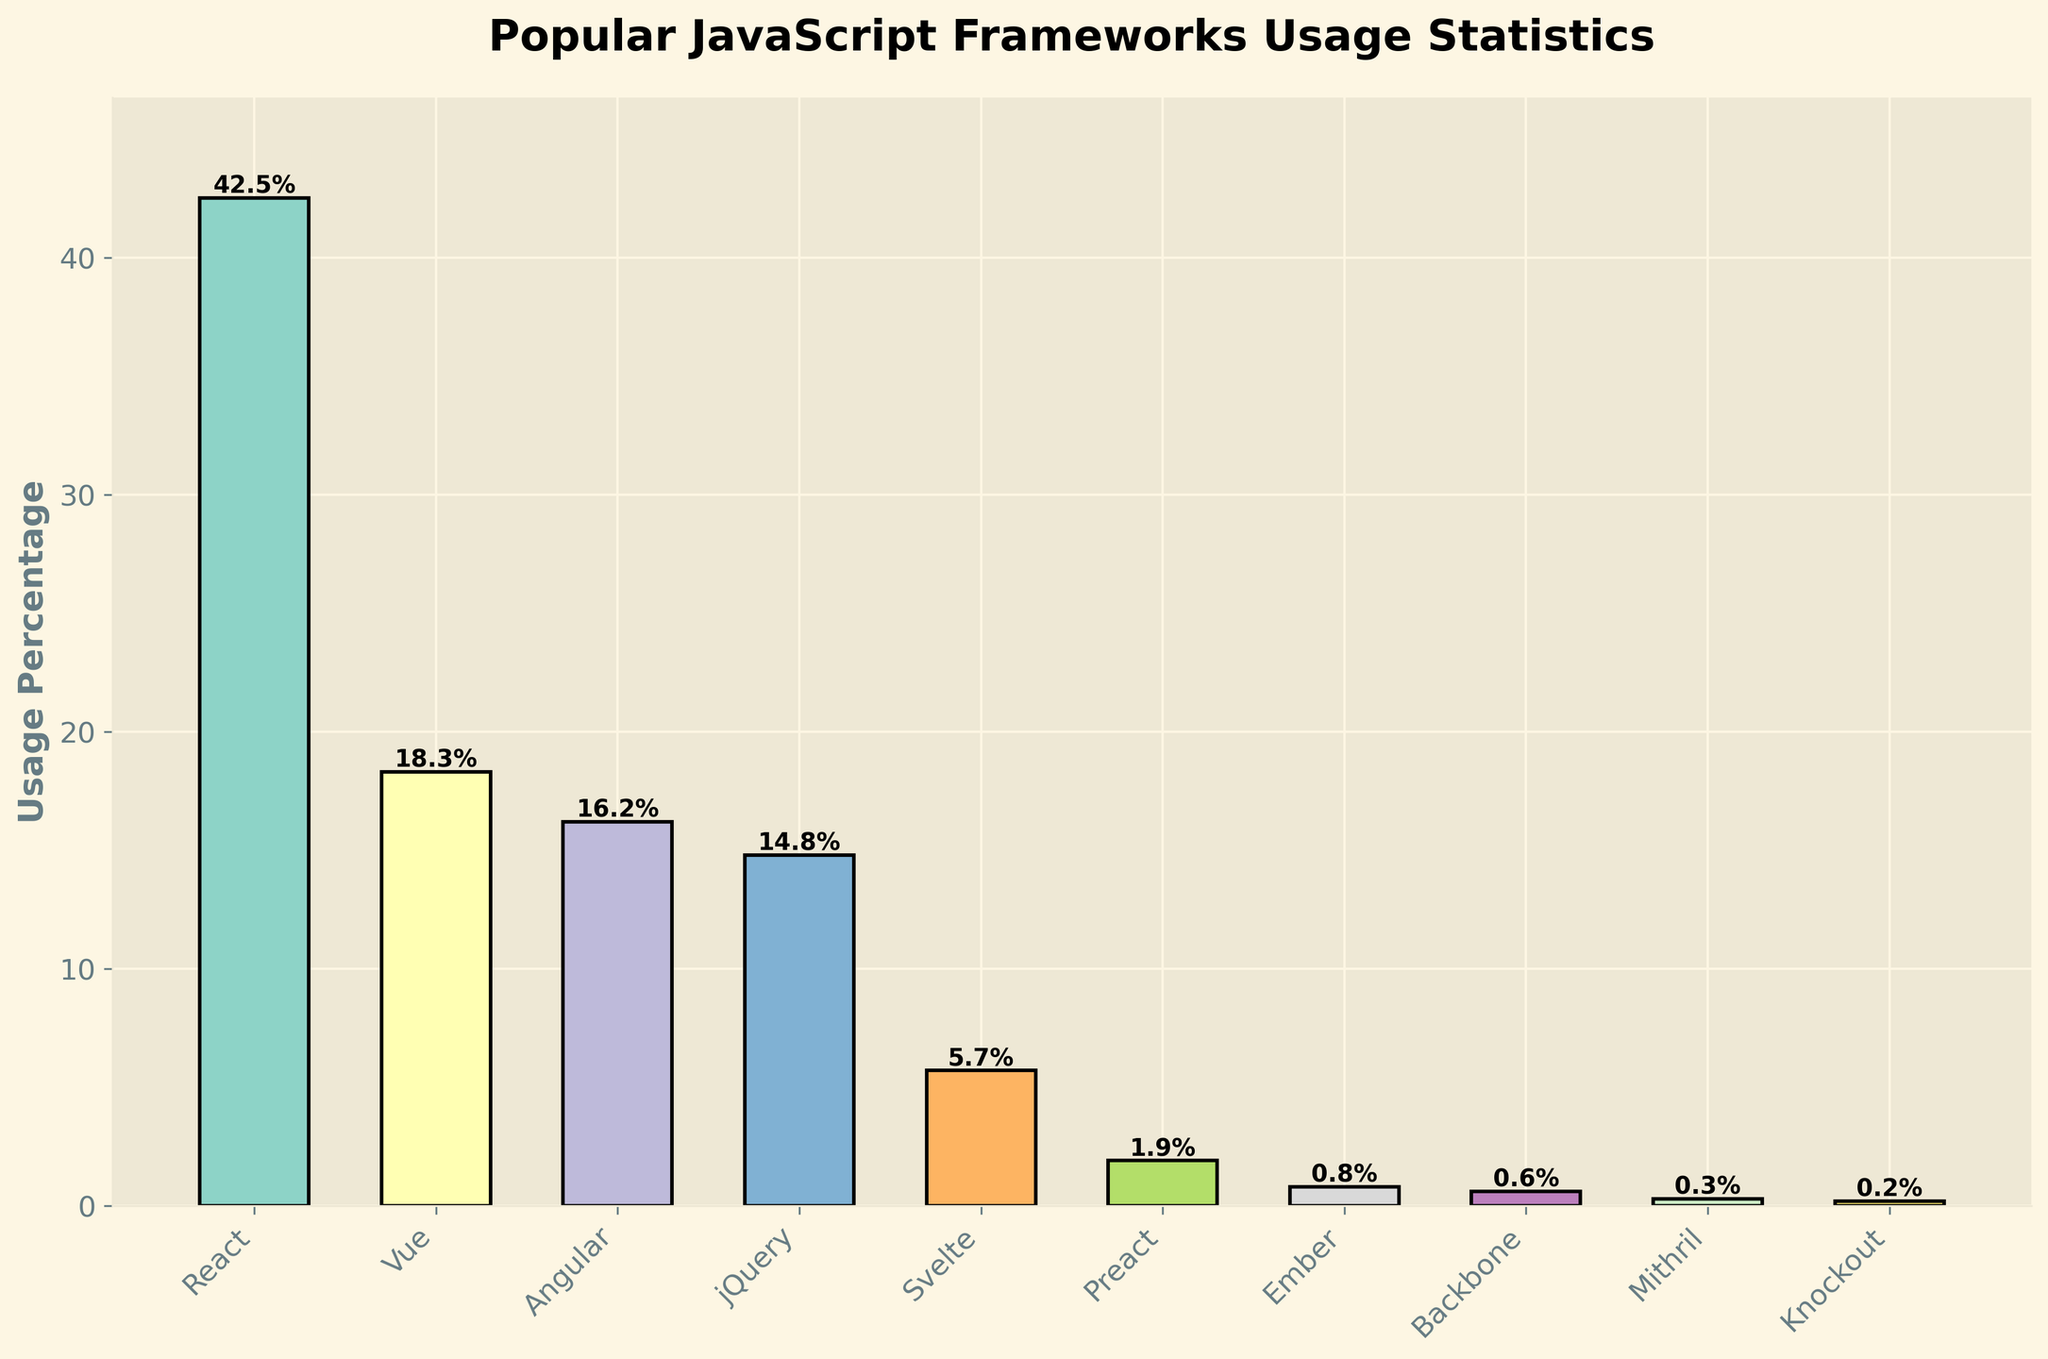Which JavaScript framework has the highest usage percentage? The tallest bar on the chart represents the JavaScript framework with the highest usage percentage. It is labeled as React.
Answer: React Which framework has the lowest usage percentage? The shortest bar indicates the framework with the lowest percentage. This bar is labeled as Knockout.
Answer: Knockout What's the total usage percentage for React, Angular, and Vue combined? Add the percentages for React (42.5), Angular (16.2), and Vue (18.3). The total is 42.5 + 16.2 + 18.3 = 77.0.
Answer: 77.0 Is the usage percentage of jQuery higher or lower than Angular? Compare the heights of the bars labeled jQuery (14.8) and Angular (16.2). jQuery's is lower.
Answer: Lower How much more popular is React compared to Svelte? Subtract Svelte’s usage percentage (5.7) from React’s (42.5). 42.5 - 5.7 = 36.8.
Answer: 36.8 Which two frameworks have the closest usage percentages? The bars for Angular (16.2) and jQuery (14.8) are closest in height; the difference is 16.2 - 14.8 = 1.4.
Answer: Angular and jQuery What percentage of developers use frameworks other than React? Subtract React’s percentage (42.5) from 100. 100 - 42.5 = 57.5.
Answer: 57.5 What is the average usage percentage of all the frameworks listed? Sum the percentages and divide by the number of frameworks. (42.5 + 18.3 + 16.2 + 14.8 + 5.7 + 1.9 + 0.8 + 0.6 + 0.3 + 0.2) / 10 = 10.13.
Answer: 10.13 If you combine the usage percentages of Backbone and Ember, is the total higher than Vue? Add Backbone (0.6) and Ember (0.8) to get 1.4. Compare to Vue’s 18.3. 1.4 is less than 18.3.
Answer: No What is the total usage percentage of the frameworks with less than 1% usage? Sum the percentages for Ember (0.8), Backbone (0.6), Mithril (0.3), and Knockout (0.2). 0.8 + 0.6 + 0.3 + 0.2 = 1.9.
Answer: 1.9 